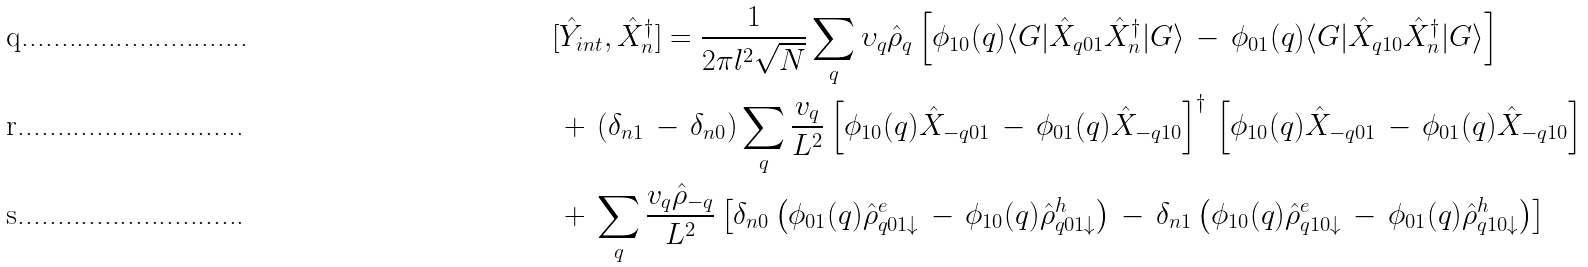Convert formula to latex. <formula><loc_0><loc_0><loc_500><loc_500>& [ \hat { Y } _ { i n t } , \hat { X } _ { n } ^ { \dag } ] = \frac { 1 } { 2 \pi l ^ { 2 } \sqrt { N } } \sum _ { q } \upsilon _ { q } \hat { \rho } _ { q } \left [ \phi _ { 1 0 } ( { q } ) \langle G | \hat { X } _ { { q } 0 1 } \hat { X } ^ { \dag } _ { n } | G \rangle \, - \, \phi _ { 0 1 } ( { q } ) \langle G | \hat { X } _ { { q } 1 0 } \hat { X } ^ { \dag } _ { n } | G \rangle \right ] \\ & \, + \, ( \delta _ { n 1 } \, - \, \delta _ { n 0 } ) \sum _ { q } \frac { v _ { q } } { L ^ { 2 } } \left [ \phi _ { 1 0 } ( { q } ) \hat { X } _ { - { q } 0 1 } \, - \, \phi _ { 0 1 } ( { q } ) \hat { X } _ { - { q } 1 0 } \right ] ^ { \dag } \, \left [ \phi _ { 1 0 } ( { q } ) \hat { X } _ { - { q } 0 1 } \, - \, \phi _ { 0 1 } ( { q } ) \hat { X } _ { - { q } 1 0 } \right ] \\ & \, + \, \sum _ { q } \frac { v _ { q } \hat { \rho } _ { - { q } } } { L ^ { 2 } } \left [ \delta _ { n 0 } \left ( \phi _ { 0 1 } ( { q } ) \hat { \rho } ^ { e } _ { { q } 0 1 \downarrow } \, - \, \phi _ { 1 0 } ( { q } ) \hat { \rho } ^ { h } _ { { q } 0 1 \downarrow } \right ) \, - \, \delta _ { n 1 } \left ( \phi _ { 1 0 } ( { q } ) \hat { \rho } ^ { e } _ { { q } 1 0 \downarrow } \, - \, \phi _ { 0 1 } ( { q } ) \hat { \rho } ^ { h } _ { { q } 1 0 \downarrow } \right ) \right ]</formula> 